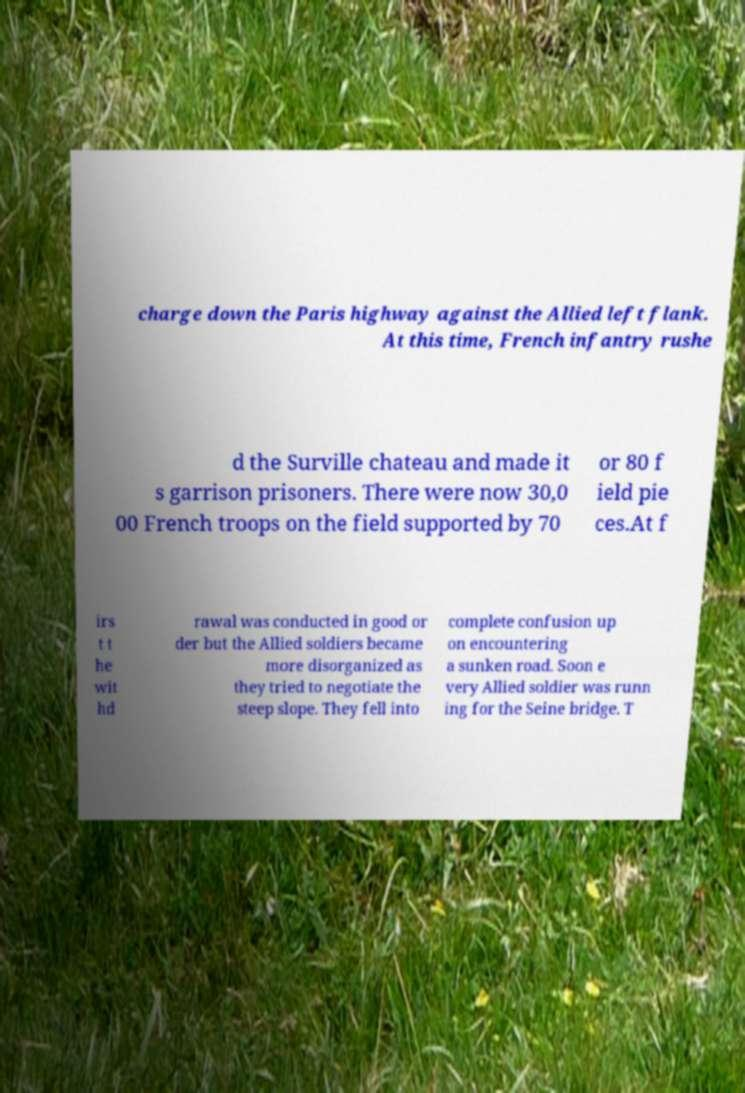Can you read and provide the text displayed in the image?This photo seems to have some interesting text. Can you extract and type it out for me? charge down the Paris highway against the Allied left flank. At this time, French infantry rushe d the Surville chateau and made it s garrison prisoners. There were now 30,0 00 French troops on the field supported by 70 or 80 f ield pie ces.At f irs t t he wit hd rawal was conducted in good or der but the Allied soldiers became more disorganized as they tried to negotiate the steep slope. They fell into complete confusion up on encountering a sunken road. Soon e very Allied soldier was runn ing for the Seine bridge. T 